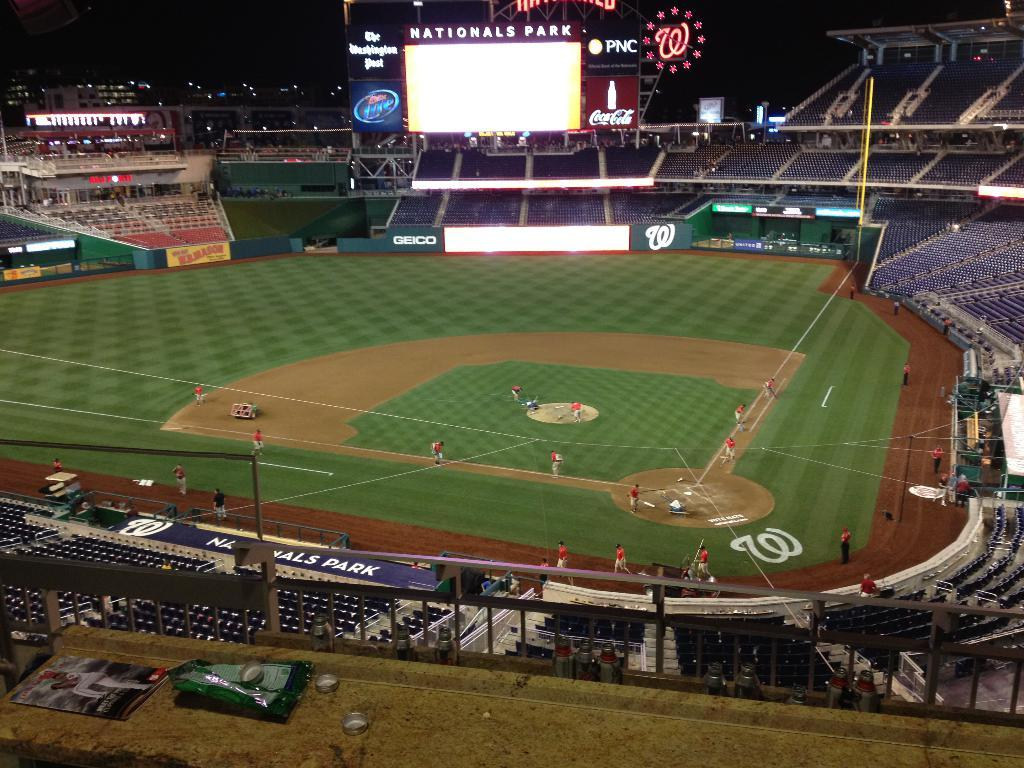What type of location is depicted in the image? The image appears to be a stadium. What can be seen on the ground in the image? There are people on the ground in the image. What type of seating is available in the image? There are chairs in the image. What other structures are present in the image? There are boards and poles in the image. What type of display can be seen in the image? There is a screen in the image. What is the color of the background in the image? The background of the image is dark. How many cars are parked in the stadium in the image? There are no cars visible in the image; the image depicts a stadium with people, chairs, boards, poles, and a screen. Is there any evidence of a crime occurring in the image? There is no indication of any crime or criminal activity in the image. 